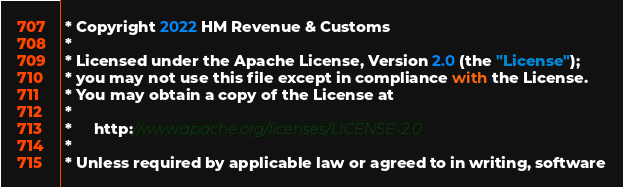Convert code to text. <code><loc_0><loc_0><loc_500><loc_500><_Scala_> * Copyright 2022 HM Revenue & Customs
 *
 * Licensed under the Apache License, Version 2.0 (the "License");
 * you may not use this file except in compliance with the License.
 * You may obtain a copy of the License at
 *
 *     http://www.apache.org/licenses/LICENSE-2.0
 *
 * Unless required by applicable law or agreed to in writing, software</code> 